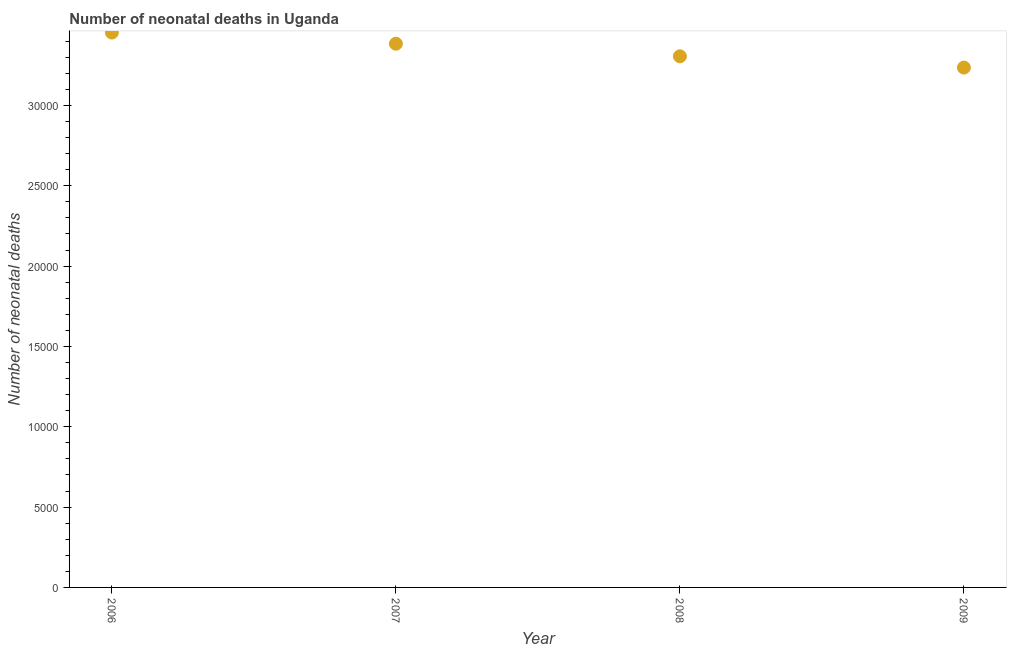What is the number of neonatal deaths in 2008?
Provide a short and direct response. 3.31e+04. Across all years, what is the maximum number of neonatal deaths?
Your answer should be compact. 3.45e+04. Across all years, what is the minimum number of neonatal deaths?
Your answer should be compact. 3.24e+04. What is the sum of the number of neonatal deaths?
Your answer should be very brief. 1.34e+05. What is the difference between the number of neonatal deaths in 2007 and 2009?
Provide a succinct answer. 1485. What is the average number of neonatal deaths per year?
Your answer should be very brief. 3.34e+04. What is the median number of neonatal deaths?
Make the answer very short. 3.34e+04. What is the ratio of the number of neonatal deaths in 2006 to that in 2007?
Provide a succinct answer. 1.02. Is the difference between the number of neonatal deaths in 2007 and 2009 greater than the difference between any two years?
Ensure brevity in your answer.  No. What is the difference between the highest and the second highest number of neonatal deaths?
Your response must be concise. 693. Is the sum of the number of neonatal deaths in 2006 and 2008 greater than the maximum number of neonatal deaths across all years?
Ensure brevity in your answer.  Yes. What is the difference between the highest and the lowest number of neonatal deaths?
Give a very brief answer. 2178. In how many years, is the number of neonatal deaths greater than the average number of neonatal deaths taken over all years?
Make the answer very short. 2. How many dotlines are there?
Offer a terse response. 1. How many years are there in the graph?
Offer a terse response. 4. What is the difference between two consecutive major ticks on the Y-axis?
Keep it short and to the point. 5000. Does the graph contain grids?
Offer a terse response. No. What is the title of the graph?
Your response must be concise. Number of neonatal deaths in Uganda. What is the label or title of the X-axis?
Provide a succinct answer. Year. What is the label or title of the Y-axis?
Ensure brevity in your answer.  Number of neonatal deaths. What is the Number of neonatal deaths in 2006?
Your answer should be compact. 3.45e+04. What is the Number of neonatal deaths in 2007?
Provide a short and direct response. 3.38e+04. What is the Number of neonatal deaths in 2008?
Your answer should be compact. 3.31e+04. What is the Number of neonatal deaths in 2009?
Give a very brief answer. 3.24e+04. What is the difference between the Number of neonatal deaths in 2006 and 2007?
Your response must be concise. 693. What is the difference between the Number of neonatal deaths in 2006 and 2008?
Offer a terse response. 1477. What is the difference between the Number of neonatal deaths in 2006 and 2009?
Your response must be concise. 2178. What is the difference between the Number of neonatal deaths in 2007 and 2008?
Your response must be concise. 784. What is the difference between the Number of neonatal deaths in 2007 and 2009?
Your answer should be very brief. 1485. What is the difference between the Number of neonatal deaths in 2008 and 2009?
Provide a short and direct response. 701. What is the ratio of the Number of neonatal deaths in 2006 to that in 2007?
Make the answer very short. 1.02. What is the ratio of the Number of neonatal deaths in 2006 to that in 2008?
Your answer should be compact. 1.04. What is the ratio of the Number of neonatal deaths in 2006 to that in 2009?
Give a very brief answer. 1.07. What is the ratio of the Number of neonatal deaths in 2007 to that in 2009?
Provide a short and direct response. 1.05. 